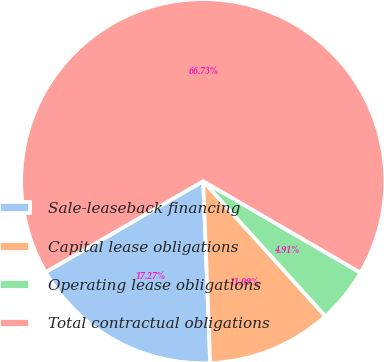<chart> <loc_0><loc_0><loc_500><loc_500><pie_chart><fcel>Sale-leaseback financing<fcel>Capital lease obligations<fcel>Operating lease obligations<fcel>Total contractual obligations<nl><fcel>17.27%<fcel>11.09%<fcel>4.91%<fcel>66.72%<nl></chart> 